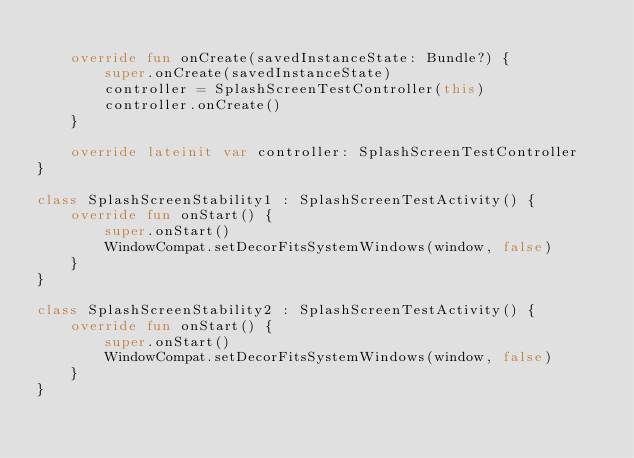<code> <loc_0><loc_0><loc_500><loc_500><_Kotlin_>
    override fun onCreate(savedInstanceState: Bundle?) {
        super.onCreate(savedInstanceState)
        controller = SplashScreenTestController(this)
        controller.onCreate()
    }

    override lateinit var controller: SplashScreenTestController
}

class SplashScreenStability1 : SplashScreenTestActivity() {
    override fun onStart() {
        super.onStart()
        WindowCompat.setDecorFitsSystemWindows(window, false)
    }
}

class SplashScreenStability2 : SplashScreenTestActivity() {
    override fun onStart() {
        super.onStart()
        WindowCompat.setDecorFitsSystemWindows(window, false)
    }
}
</code> 